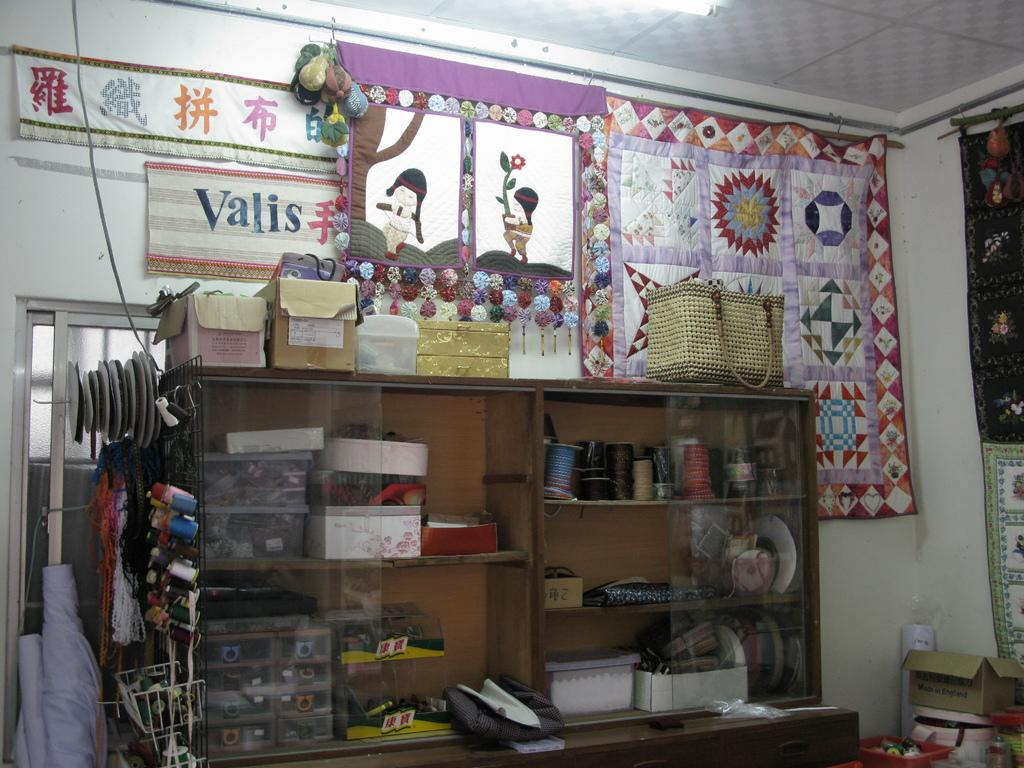<image>
Present a compact description of the photo's key features. The word Valis can be seen on a fabric on the wall in a room. 